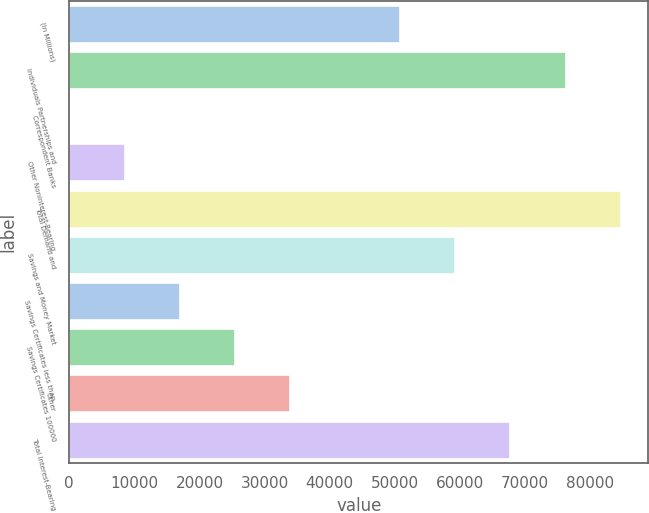<chart> <loc_0><loc_0><loc_500><loc_500><bar_chart><fcel>(In Millions)<fcel>Individuals Partnerships and<fcel>Correspondent Banks<fcel>Other Noninterest-Bearing<fcel>Total Demand and<fcel>Savings and Money Market<fcel>Savings Certificates less than<fcel>Savings Certificates 100000<fcel>Other<fcel>Total Interest-Bearing<nl><fcel>50825.5<fcel>76198.8<fcel>78.9<fcel>8536.67<fcel>84656.6<fcel>59283.3<fcel>16994.4<fcel>25452.2<fcel>33910<fcel>67741.1<nl></chart> 